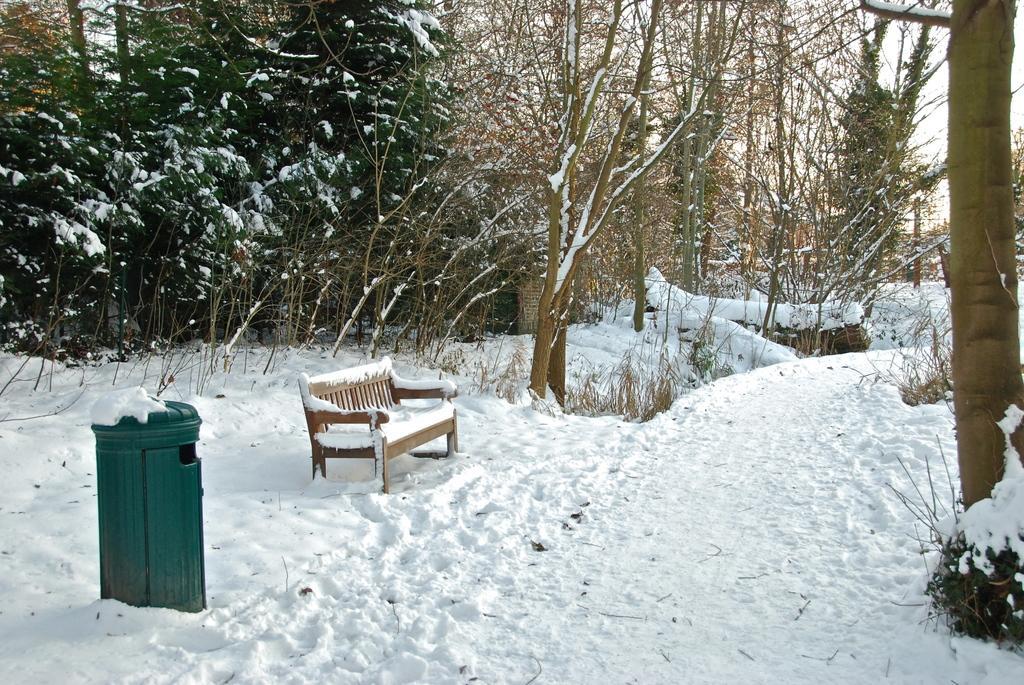In one or two sentences, can you explain what this image depicts? In this image there is a dustbin and bench covered with the snow and there are in snow and at the back ground there are trees, sky and plants. 